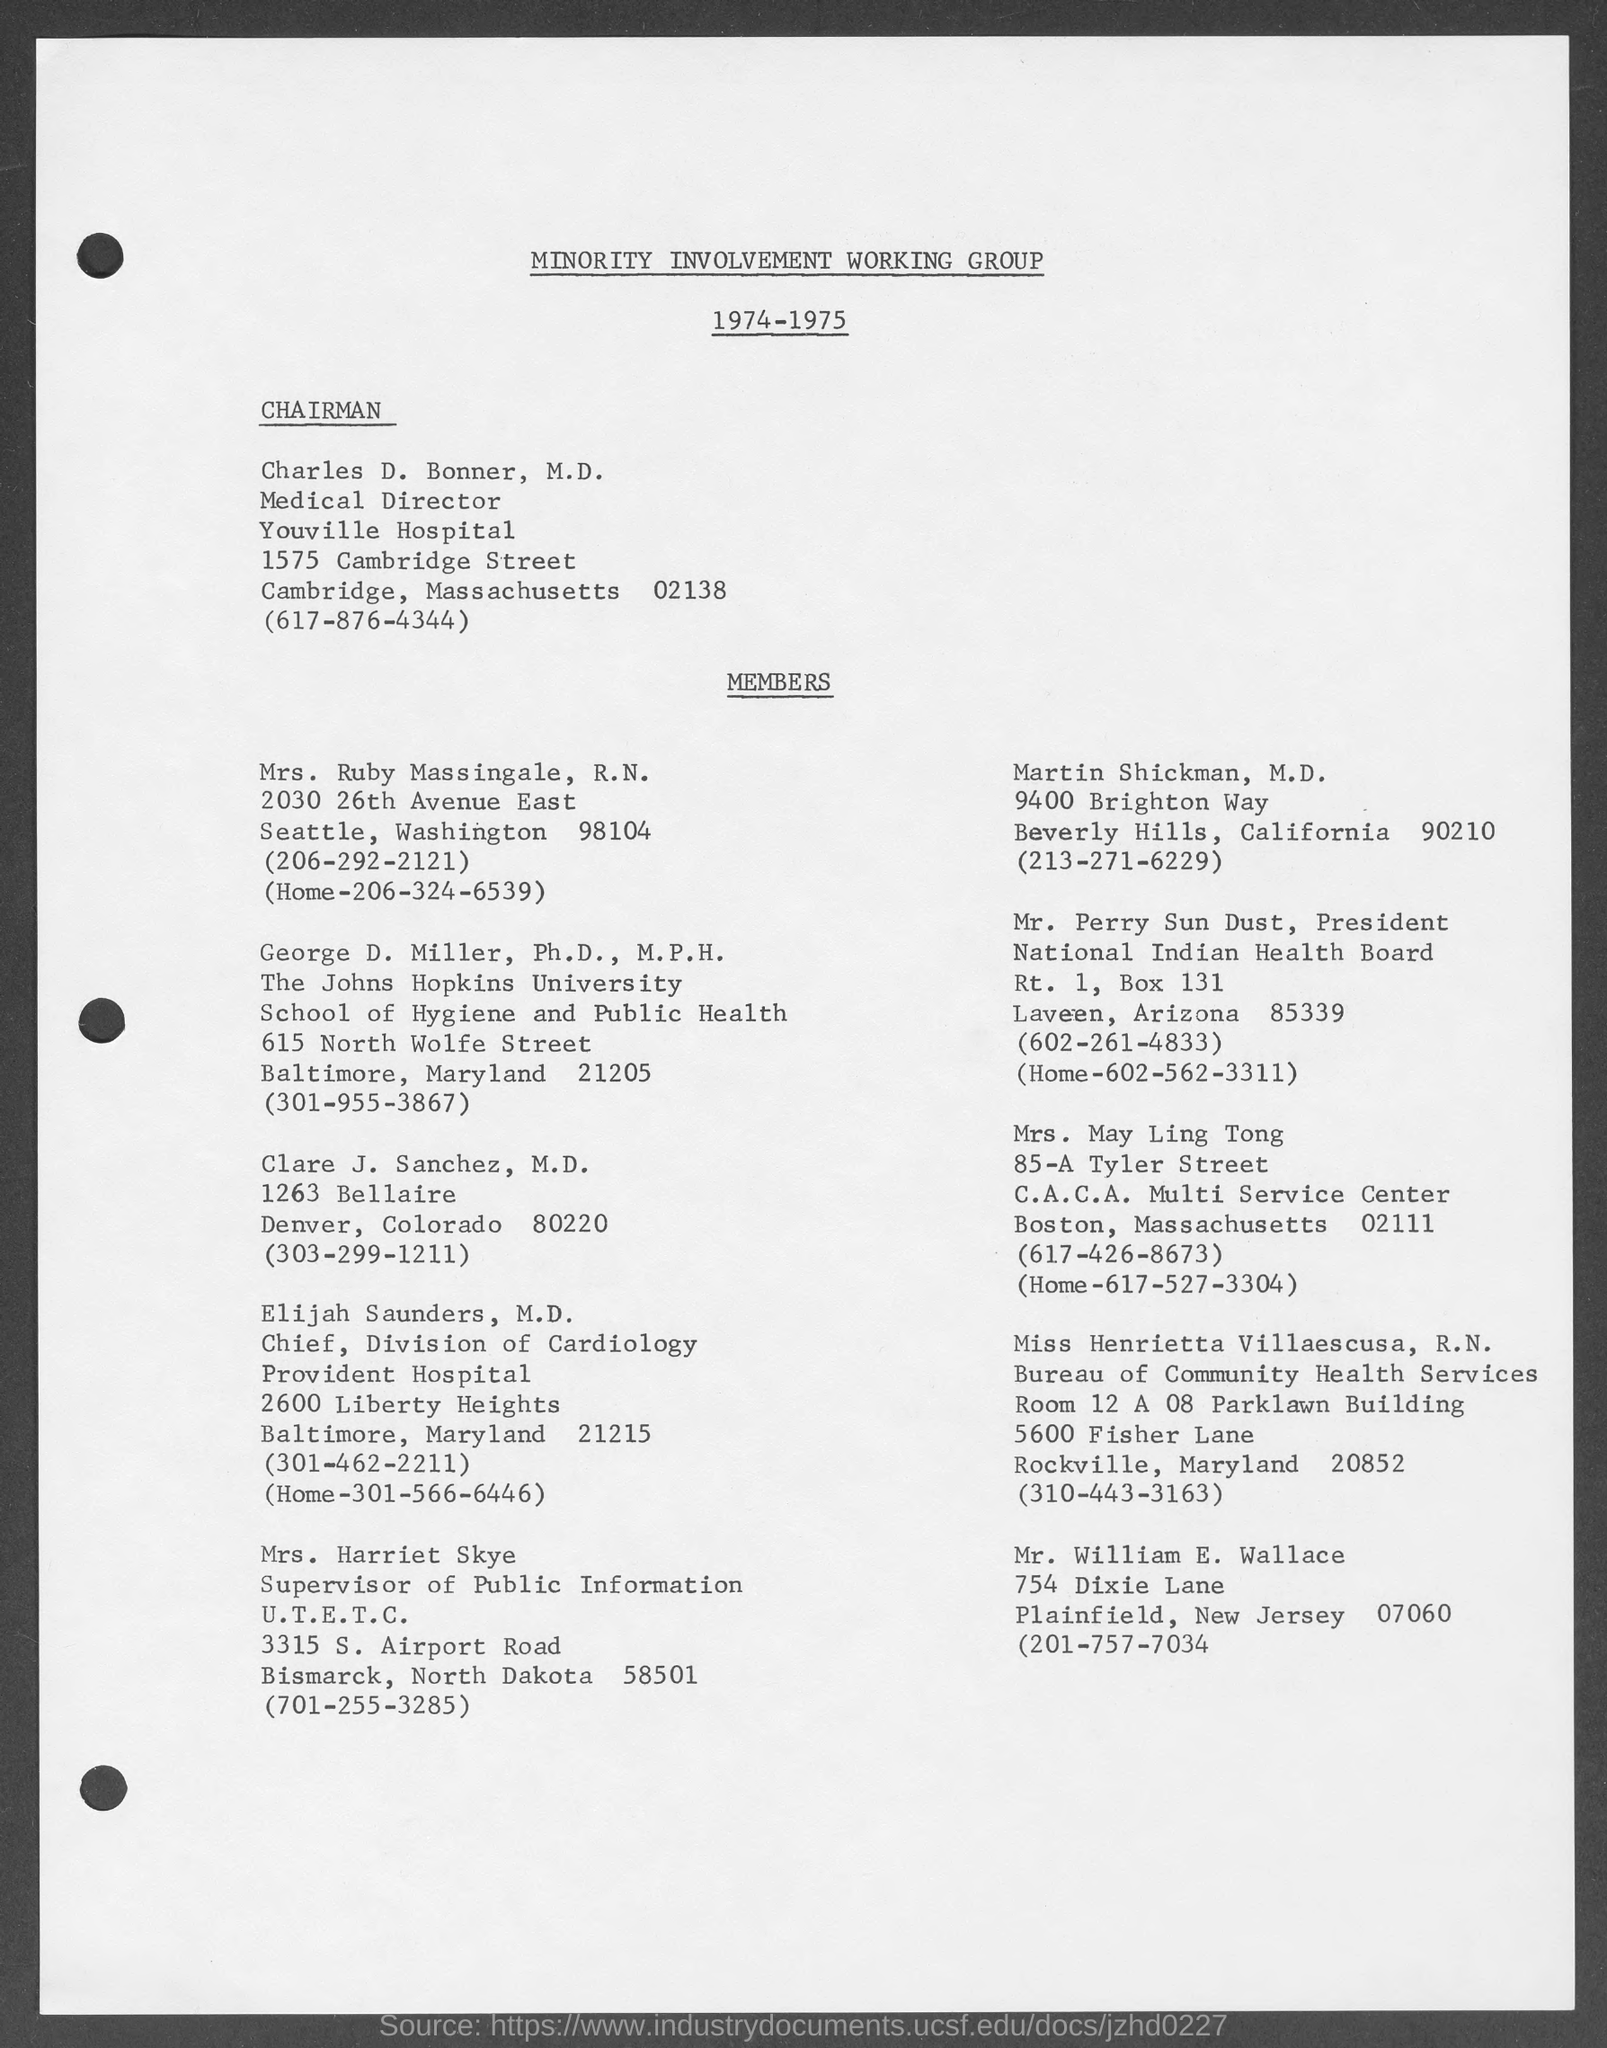Draw attention to some important aspects in this diagram. George D. Miller belongs to the Johns Hopkins University. The Minority Involvement Working Group is a specific name of a working group that was mentioned in a given page. 